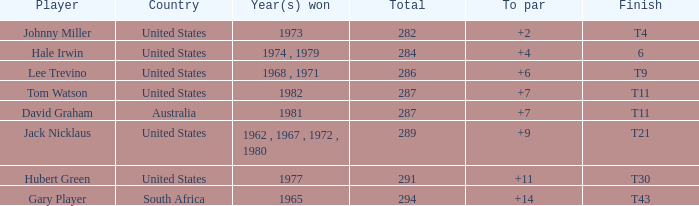WHAT IS THE TOTAL THAT HAS A WIN IN 1982? 287.0. 